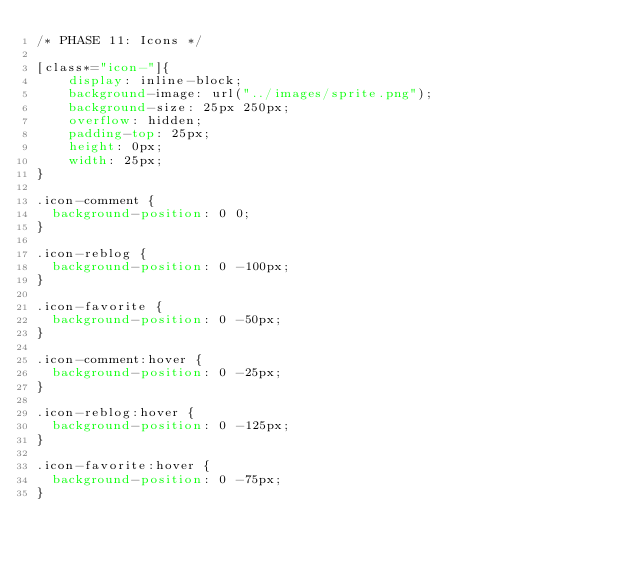Convert code to text. <code><loc_0><loc_0><loc_500><loc_500><_CSS_>/* PHASE 11: Icons */

[class*="icon-"]{
    display: inline-block;
    background-image: url("../images/sprite.png");
    background-size: 25px 250px;
    overflow: hidden;
    padding-top: 25px;
    height: 0px;
    width: 25px;
}

.icon-comment {
  background-position: 0 0;
}

.icon-reblog {
  background-position: 0 -100px;
}

.icon-favorite {
  background-position: 0 -50px;
}

.icon-comment:hover {
  background-position: 0 -25px;
}

.icon-reblog:hover {
  background-position: 0 -125px;
}

.icon-favorite:hover {
  background-position: 0 -75px;
}</code> 